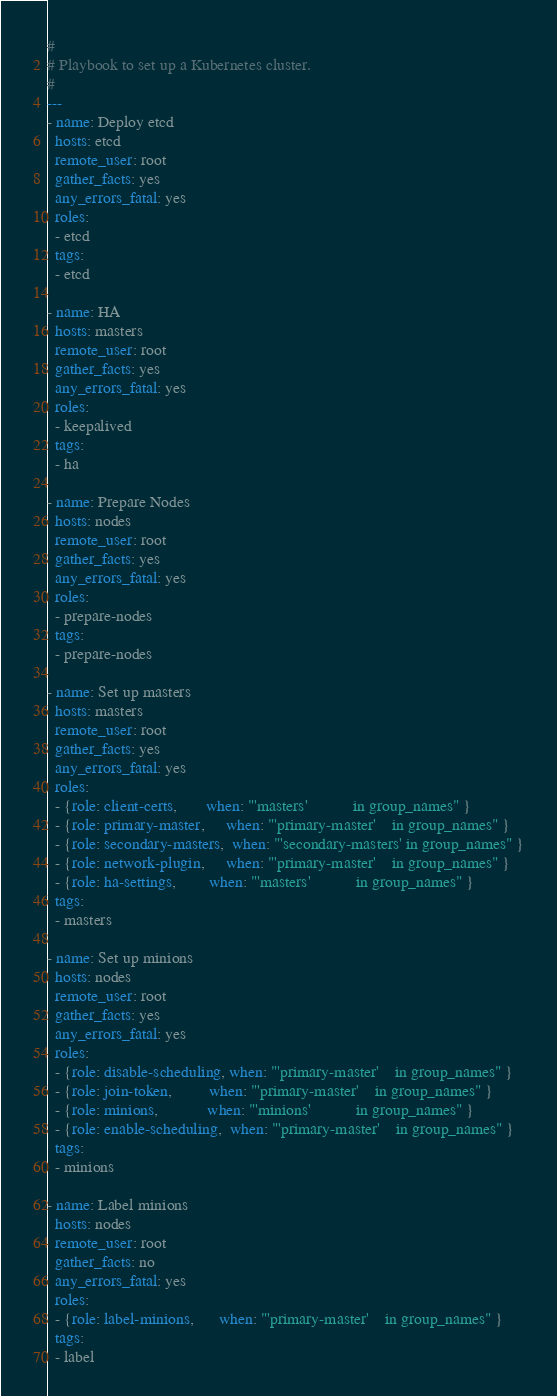Convert code to text. <code><loc_0><loc_0><loc_500><loc_500><_YAML_>#
# Playbook to set up a Kubernetes cluster.
#
--- 
- name: Deploy etcd
  hosts: etcd
  remote_user: root
  gather_facts: yes
  any_errors_fatal: yes
  roles:
  - etcd
  tags:
  - etcd

- name: HA
  hosts: masters
  remote_user: root
  gather_facts: yes
  any_errors_fatal: yes
  roles:
  - keepalived
  tags:
  - ha

- name: Prepare Nodes
  hosts: nodes
  remote_user: root
  gather_facts: yes
  any_errors_fatal: yes
  roles:
  - prepare-nodes
  tags:
  - prepare-nodes

- name: Set up masters
  hosts: masters
  remote_user: root
  gather_facts: yes
  any_errors_fatal: yes
  roles:
  - {role: client-certs,       when: "'masters'           in group_names" }
  - {role: primary-master,     when: "'primary-master'    in group_names" }
  - {role: secondary-masters,  when: "'secondary-masters' in group_names" }
  - {role: network-plugin,     when: "'primary-master'    in group_names" }
  - {role: ha-settings,        when: "'masters'           in group_names" }
  tags:
  - masters

- name: Set up minions
  hosts: nodes
  remote_user: root
  gather_facts: yes
  any_errors_fatal: yes
  roles:
  - {role: disable-scheduling, when: "'primary-master'    in group_names" }
  - {role: join-token,         when: "'primary-master'    in group_names" }
  - {role: minions,            when: "'minions'           in group_names" }
  - {role: enable-scheduling,  when: "'primary-master'    in group_names" }
  tags:
  - minions

- name: Label minions
  hosts: nodes
  remote_user: root
  gather_facts: no
  any_errors_fatal: yes
  roles:
  - {role: label-minions,      when: "'primary-master'    in group_names" }
  tags:
  - label
</code> 